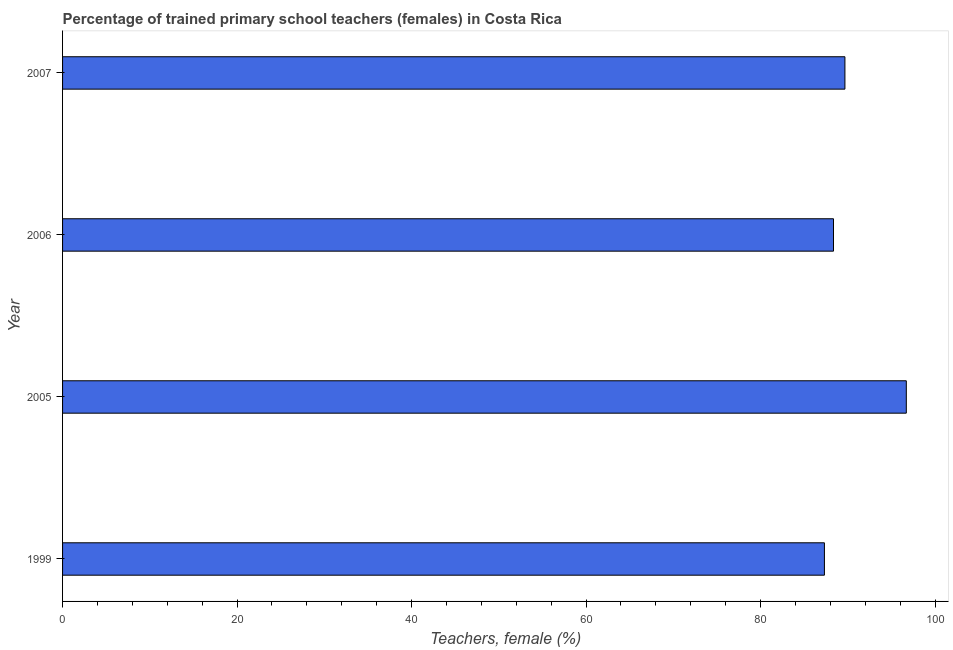What is the title of the graph?
Your answer should be compact. Percentage of trained primary school teachers (females) in Costa Rica. What is the label or title of the X-axis?
Offer a terse response. Teachers, female (%). What is the label or title of the Y-axis?
Your response must be concise. Year. What is the percentage of trained female teachers in 2005?
Provide a short and direct response. 96.7. Across all years, what is the maximum percentage of trained female teachers?
Offer a very short reply. 96.7. Across all years, what is the minimum percentage of trained female teachers?
Provide a succinct answer. 87.32. In which year was the percentage of trained female teachers maximum?
Make the answer very short. 2005. What is the sum of the percentage of trained female teachers?
Give a very brief answer. 362.04. What is the difference between the percentage of trained female teachers in 1999 and 2005?
Provide a succinct answer. -9.38. What is the average percentage of trained female teachers per year?
Provide a succinct answer. 90.51. What is the median percentage of trained female teachers?
Offer a very short reply. 89.01. In how many years, is the percentage of trained female teachers greater than 64 %?
Your answer should be compact. 4. Is the difference between the percentage of trained female teachers in 2006 and 2007 greater than the difference between any two years?
Make the answer very short. No. What is the difference between the highest and the second highest percentage of trained female teachers?
Offer a very short reply. 7.04. Is the sum of the percentage of trained female teachers in 2005 and 2006 greater than the maximum percentage of trained female teachers across all years?
Ensure brevity in your answer.  Yes. What is the difference between the highest and the lowest percentage of trained female teachers?
Give a very brief answer. 9.38. How many years are there in the graph?
Give a very brief answer. 4. Are the values on the major ticks of X-axis written in scientific E-notation?
Offer a terse response. No. What is the Teachers, female (%) of 1999?
Offer a very short reply. 87.32. What is the Teachers, female (%) in 2005?
Offer a terse response. 96.7. What is the Teachers, female (%) in 2006?
Provide a short and direct response. 88.36. What is the Teachers, female (%) in 2007?
Your answer should be very brief. 89.67. What is the difference between the Teachers, female (%) in 1999 and 2005?
Provide a succinct answer. -9.38. What is the difference between the Teachers, female (%) in 1999 and 2006?
Your answer should be compact. -1.04. What is the difference between the Teachers, female (%) in 1999 and 2007?
Give a very brief answer. -2.35. What is the difference between the Teachers, female (%) in 2005 and 2006?
Provide a succinct answer. 8.34. What is the difference between the Teachers, female (%) in 2005 and 2007?
Offer a terse response. 7.04. What is the difference between the Teachers, female (%) in 2006 and 2007?
Offer a very short reply. -1.31. What is the ratio of the Teachers, female (%) in 1999 to that in 2005?
Your answer should be very brief. 0.9. What is the ratio of the Teachers, female (%) in 1999 to that in 2006?
Your answer should be very brief. 0.99. What is the ratio of the Teachers, female (%) in 2005 to that in 2006?
Provide a succinct answer. 1.09. What is the ratio of the Teachers, female (%) in 2005 to that in 2007?
Offer a very short reply. 1.08. 